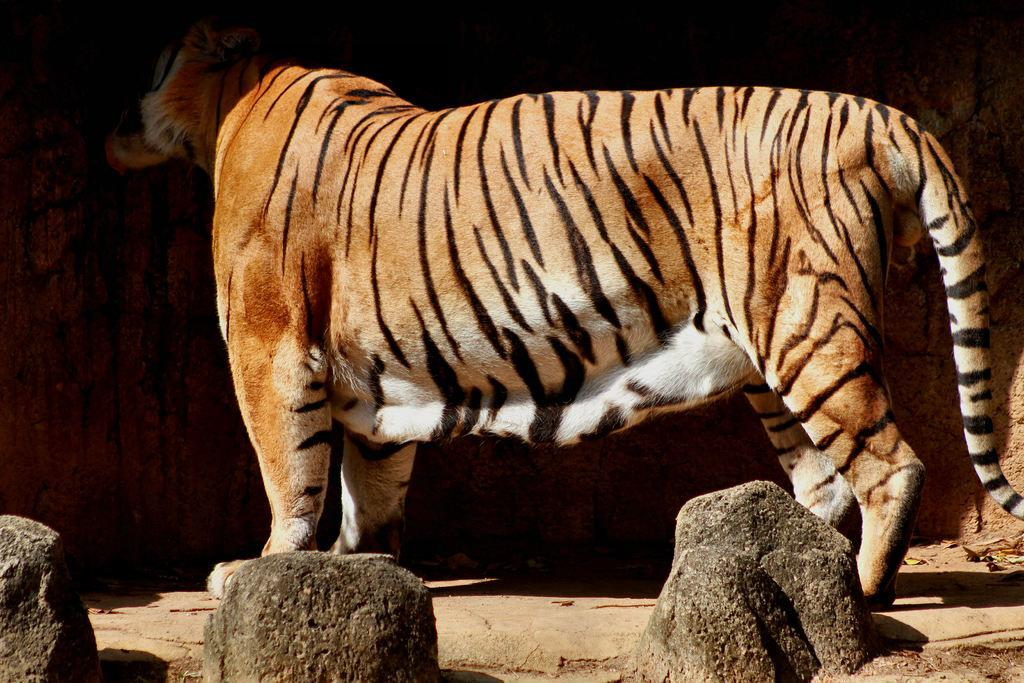What animal is present in the image? There is a tiger in the image. What is the tiger's position in relation to the ground? The tiger is standing on the ground. What type of boundary can be seen surrounding the tiger in the image? There is no boundary surrounding the tiger in the image. What type of cup is the tiger holding in the image? The tiger is not holding a cup in the image. 